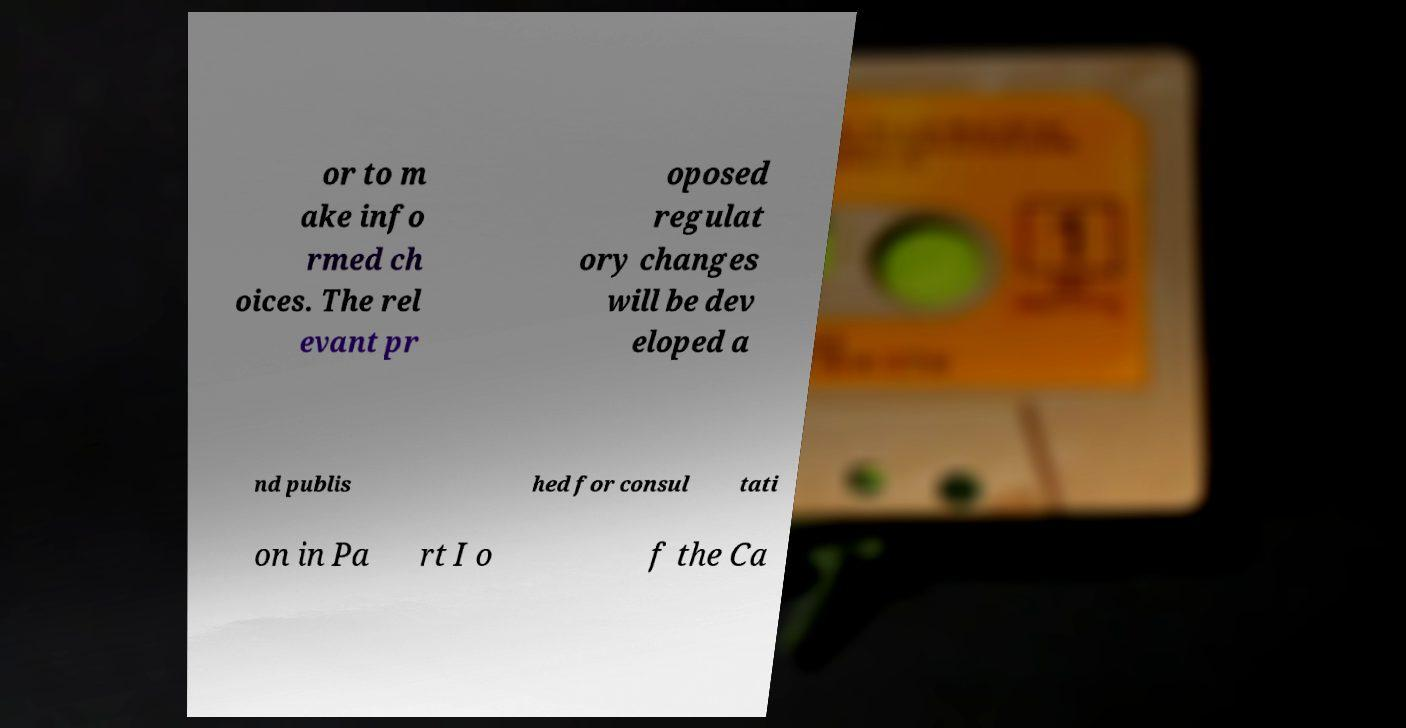There's text embedded in this image that I need extracted. Can you transcribe it verbatim? or to m ake info rmed ch oices. The rel evant pr oposed regulat ory changes will be dev eloped a nd publis hed for consul tati on in Pa rt I o f the Ca 